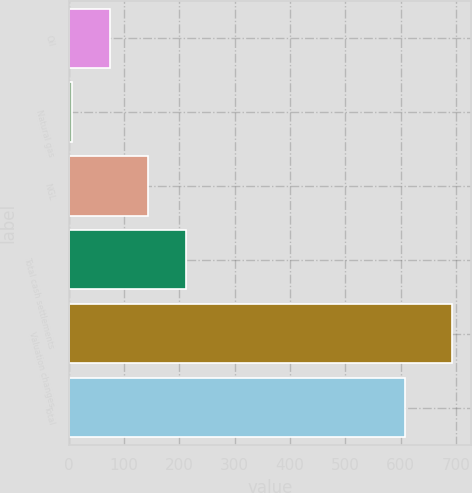<chart> <loc_0><loc_0><loc_500><loc_500><bar_chart><fcel>Oil<fcel>Natural gas<fcel>NGL<fcel>Total cash settlements<fcel>Valuation changes<fcel>Total<nl><fcel>73.7<fcel>5<fcel>142.4<fcel>211.1<fcel>692<fcel>608<nl></chart> 